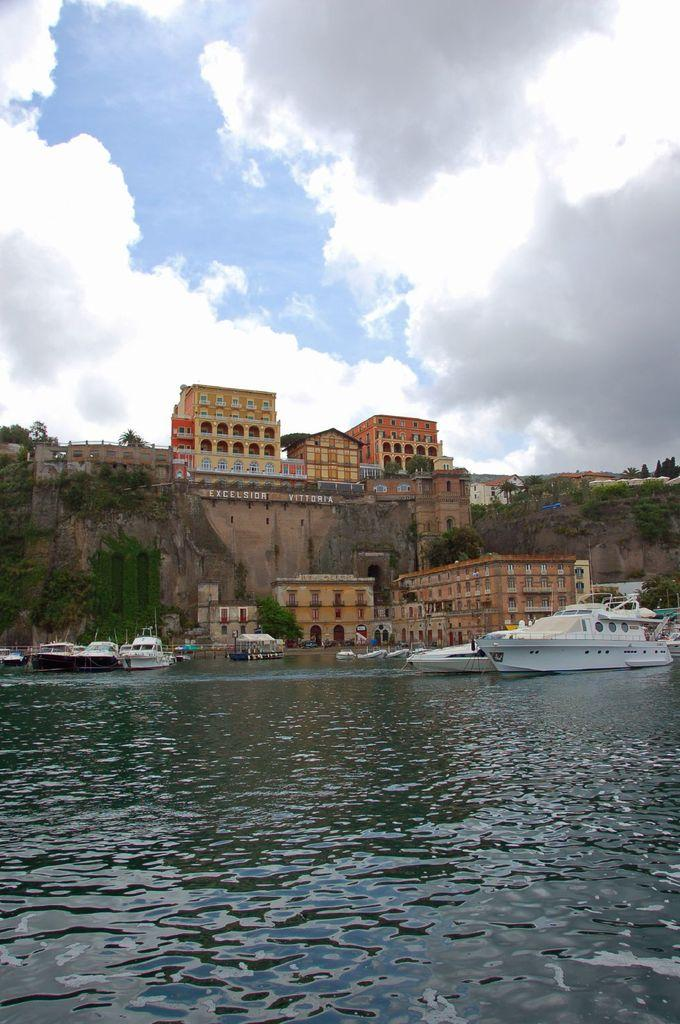What is the main subject in the center of the image? There are ships on the surface of water in the center of the image. What can be seen in the background of the image? There are buildings, a wall, greenery, and the sky visible in the background of the image. How many cows are visible on the ships in the image? There are no cows present on the ships or in the image. 